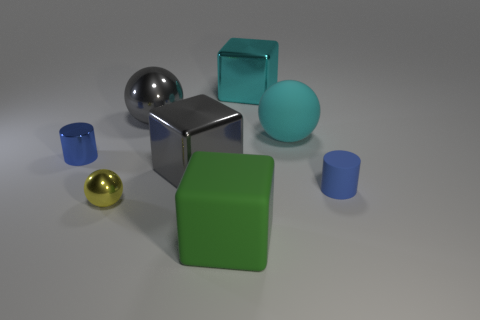Add 2 matte balls. How many objects exist? 10 Subtract all purple rubber cylinders. Subtract all small metallic things. How many objects are left? 6 Add 8 tiny blue objects. How many tiny blue objects are left? 10 Add 4 large gray shiny things. How many large gray shiny things exist? 6 Subtract 0 brown blocks. How many objects are left? 8 Subtract all cubes. How many objects are left? 5 